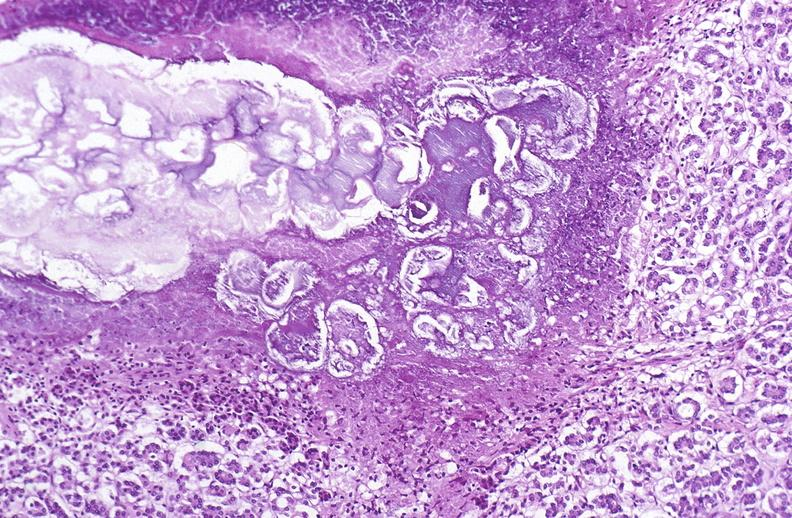what does this image show?
Answer the question using a single word or phrase. Pancreatic fat necrosis 